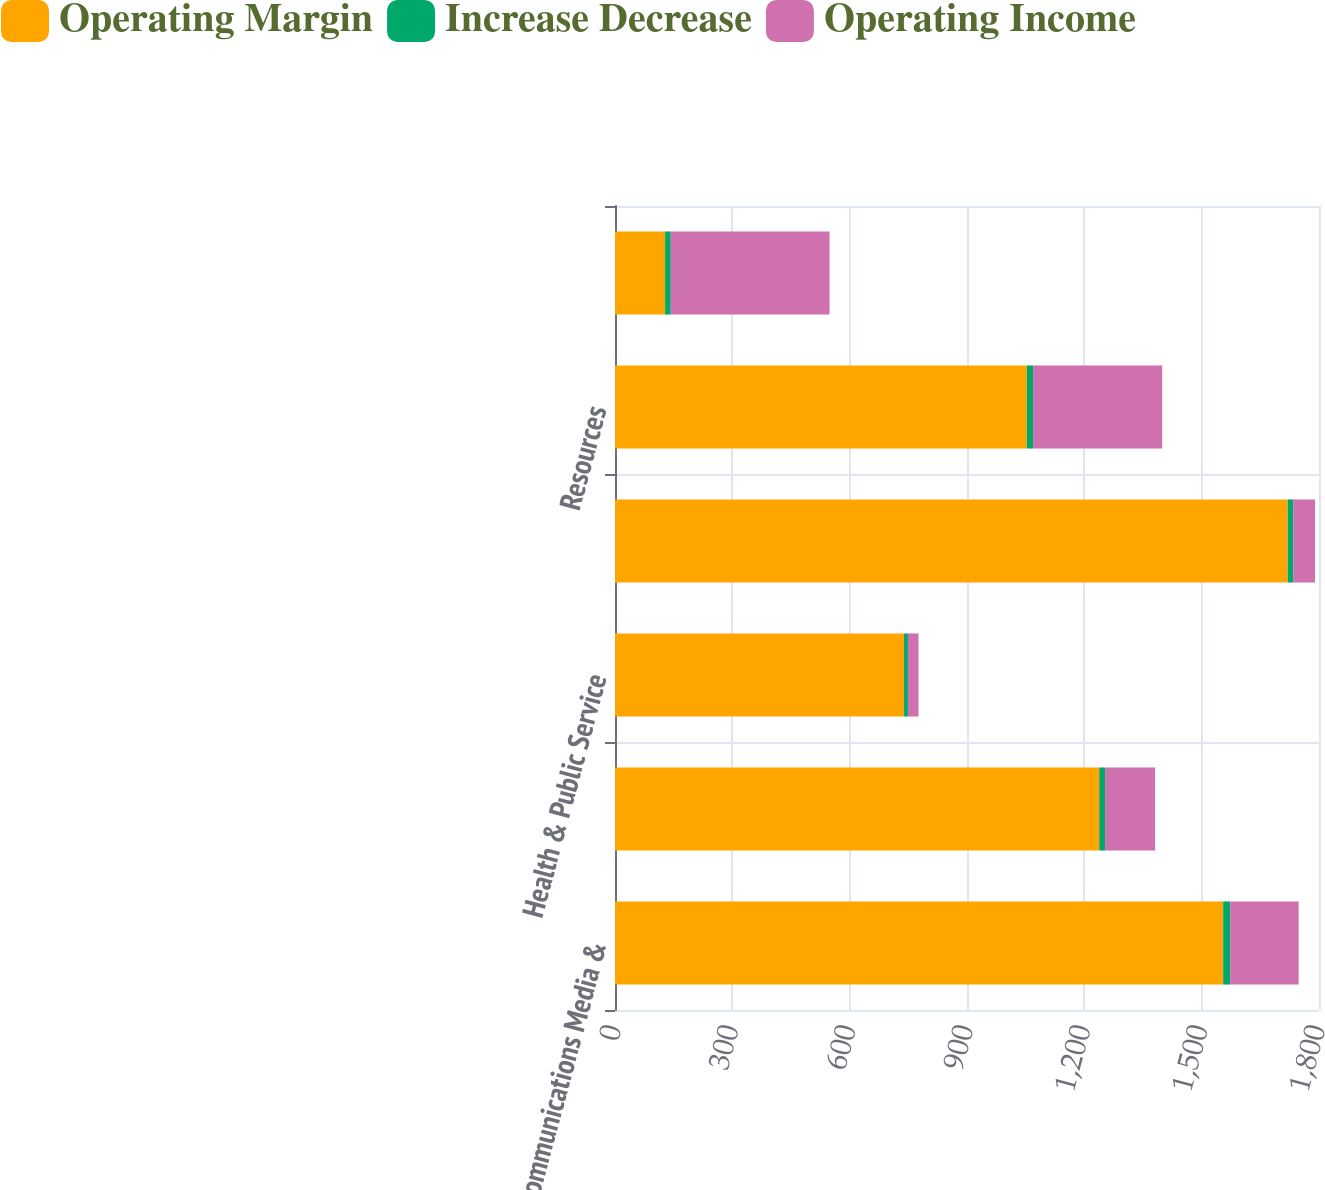Convert chart. <chart><loc_0><loc_0><loc_500><loc_500><stacked_bar_chart><ecel><fcel>Communications Media &<fcel>Financial Services<fcel>Health & Public Service<fcel>Products<fcel>Resources<fcel>TOTAL<nl><fcel>Operating Margin<fcel>1555<fcel>1238<fcel>739<fcel>1720<fcel>1053<fcel>128<nl><fcel>Increase Decrease<fcel>18<fcel>15<fcel>10<fcel>14<fcel>16<fcel>14.6<nl><fcel>Operating Income<fcel>175<fcel>128<fcel>27<fcel>56<fcel>330<fcel>406<nl></chart> 